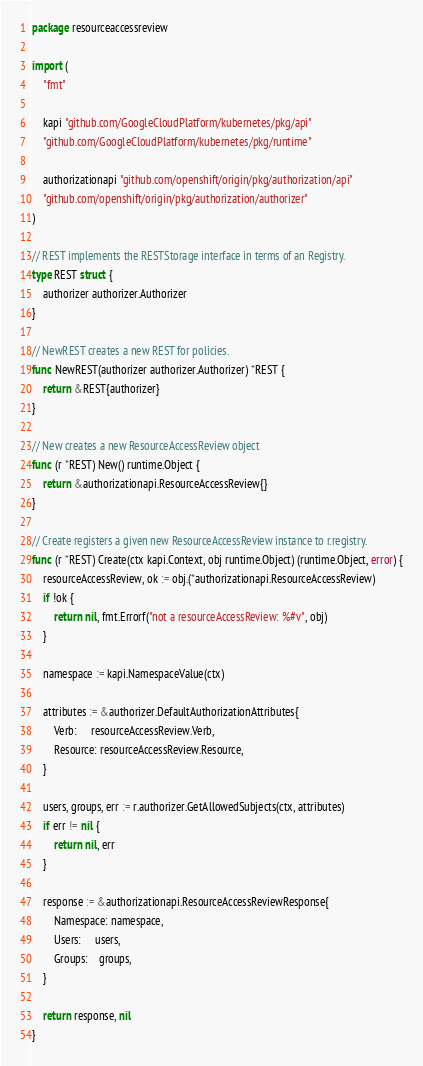<code> <loc_0><loc_0><loc_500><loc_500><_Go_>package resourceaccessreview

import (
	"fmt"

	kapi "github.com/GoogleCloudPlatform/kubernetes/pkg/api"
	"github.com/GoogleCloudPlatform/kubernetes/pkg/runtime"

	authorizationapi "github.com/openshift/origin/pkg/authorization/api"
	"github.com/openshift/origin/pkg/authorization/authorizer"
)

// REST implements the RESTStorage interface in terms of an Registry.
type REST struct {
	authorizer authorizer.Authorizer
}

// NewREST creates a new REST for policies.
func NewREST(authorizer authorizer.Authorizer) *REST {
	return &REST{authorizer}
}

// New creates a new ResourceAccessReview object
func (r *REST) New() runtime.Object {
	return &authorizationapi.ResourceAccessReview{}
}

// Create registers a given new ResourceAccessReview instance to r.registry.
func (r *REST) Create(ctx kapi.Context, obj runtime.Object) (runtime.Object, error) {
	resourceAccessReview, ok := obj.(*authorizationapi.ResourceAccessReview)
	if !ok {
		return nil, fmt.Errorf("not a resourceAccessReview: %#v", obj)
	}

	namespace := kapi.NamespaceValue(ctx)

	attributes := &authorizer.DefaultAuthorizationAttributes{
		Verb:     resourceAccessReview.Verb,
		Resource: resourceAccessReview.Resource,
	}

	users, groups, err := r.authorizer.GetAllowedSubjects(ctx, attributes)
	if err != nil {
		return nil, err
	}

	response := &authorizationapi.ResourceAccessReviewResponse{
		Namespace: namespace,
		Users:     users,
		Groups:    groups,
	}

	return response, nil
}
</code> 